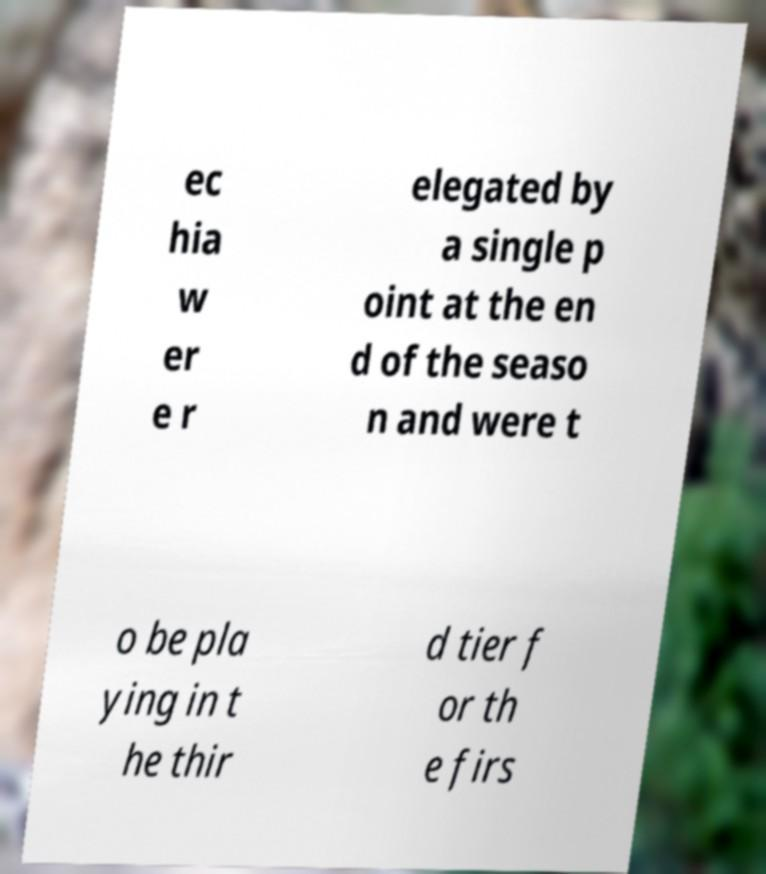Please read and relay the text visible in this image. What does it say? ec hia w er e r elegated by a single p oint at the en d of the seaso n and were t o be pla ying in t he thir d tier f or th e firs 